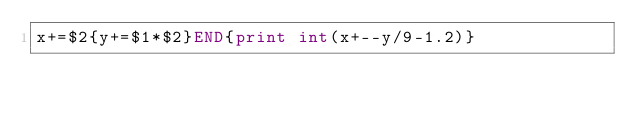Convert code to text. <code><loc_0><loc_0><loc_500><loc_500><_Awk_>x+=$2{y+=$1*$2}END{print int(x+--y/9-1.2)}</code> 